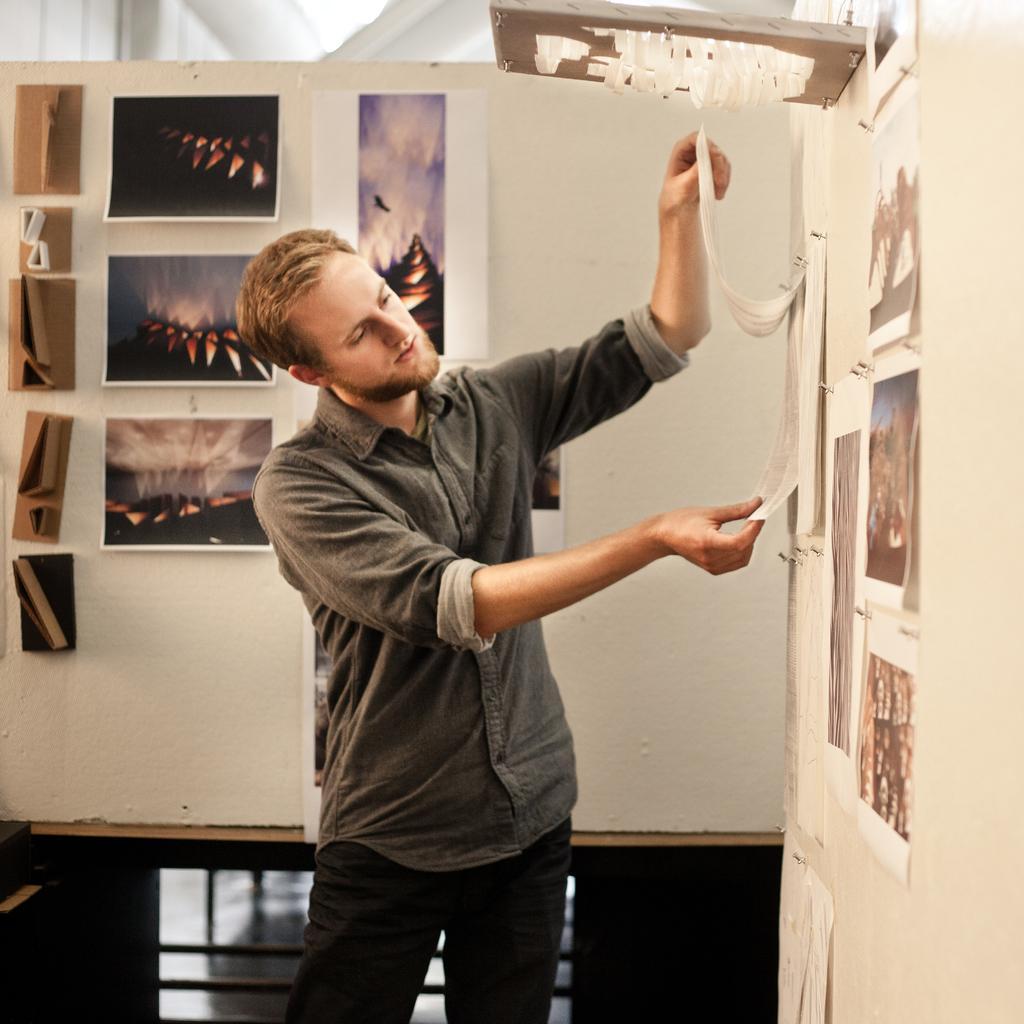How would you summarize this image in a sentence or two? Here I can see a man standing, holding a calendar and looking at that. On the right side there are few posts attached to the wall. In the background some more posters are attached to the wall. At the top of the image there is a board. 